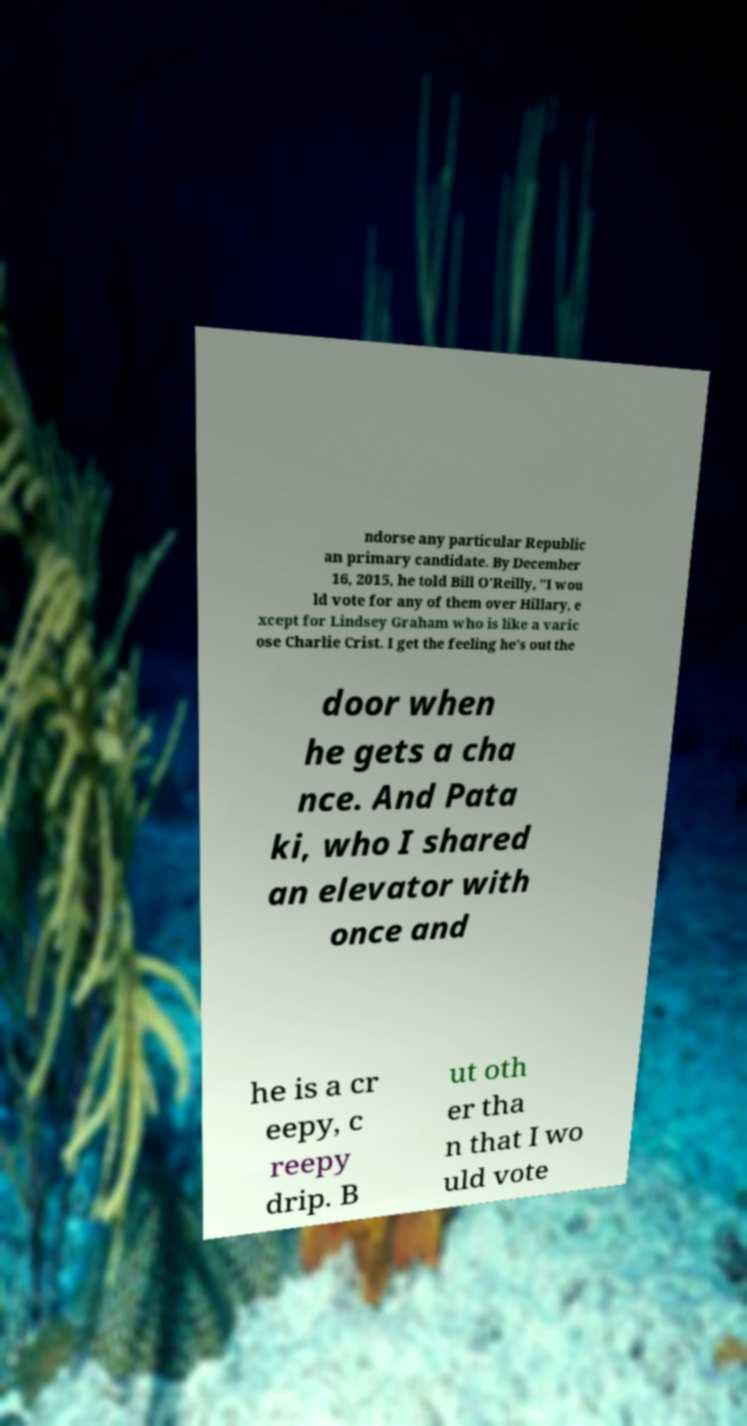Can you accurately transcribe the text from the provided image for me? ndorse any particular Republic an primary candidate. By December 16, 2015, he told Bill O'Reilly, "I wou ld vote for any of them over Hillary, e xcept for Lindsey Graham who is like a varic ose Charlie Crist. I get the feeling he's out the door when he gets a cha nce. And Pata ki, who I shared an elevator with once and he is a cr eepy, c reepy drip. B ut oth er tha n that I wo uld vote 